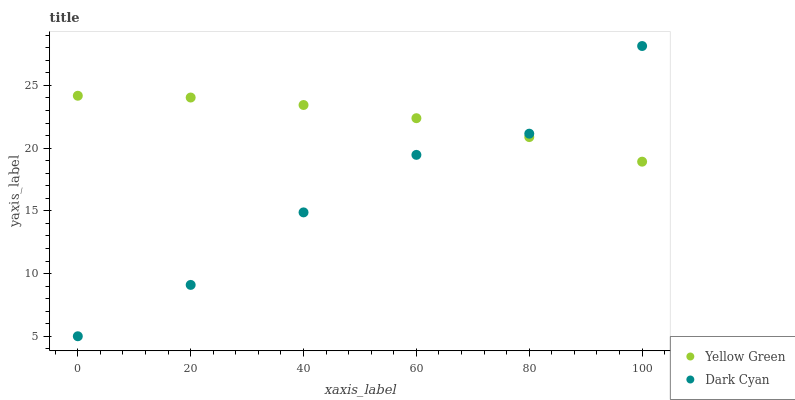Does Dark Cyan have the minimum area under the curve?
Answer yes or no. Yes. Does Yellow Green have the maximum area under the curve?
Answer yes or no. Yes. Does Yellow Green have the minimum area under the curve?
Answer yes or no. No. Is Yellow Green the smoothest?
Answer yes or no. Yes. Is Dark Cyan the roughest?
Answer yes or no. Yes. Is Yellow Green the roughest?
Answer yes or no. No. Does Dark Cyan have the lowest value?
Answer yes or no. Yes. Does Yellow Green have the lowest value?
Answer yes or no. No. Does Dark Cyan have the highest value?
Answer yes or no. Yes. Does Yellow Green have the highest value?
Answer yes or no. No. Does Yellow Green intersect Dark Cyan?
Answer yes or no. Yes. Is Yellow Green less than Dark Cyan?
Answer yes or no. No. Is Yellow Green greater than Dark Cyan?
Answer yes or no. No. 